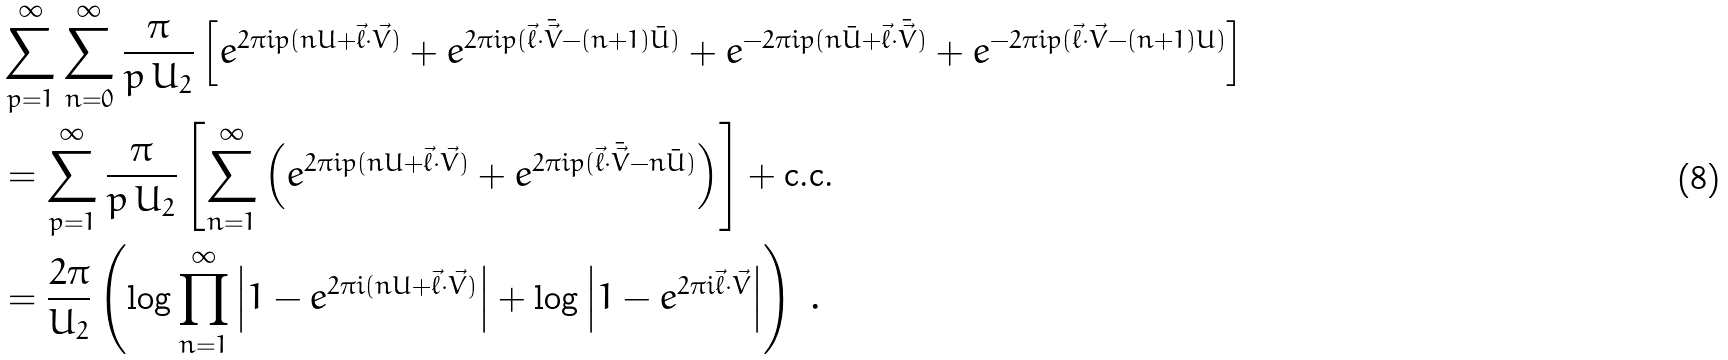Convert formula to latex. <formula><loc_0><loc_0><loc_500><loc_500>& \sum _ { p = 1 } ^ { \infty } \sum _ { n = 0 } ^ { \infty } \frac { \pi } { p \, U _ { 2 } } \left [ e ^ { 2 \pi i p ( n U + \vec { \ell } \cdot \vec { V } ) } + e ^ { 2 \pi i p ( \vec { \ell } \cdot \bar { \vec { V } } - ( n + 1 ) \bar { U } ) } + e ^ { - 2 \pi i p ( n \bar { U } + \vec { \ell } \cdot \bar { \vec { V } } ) } + e ^ { - 2 \pi i p ( \vec { \ell } \cdot \vec { V } - ( n + 1 ) U ) } \right ] \\ & = \sum _ { p = 1 } ^ { \infty } \frac { \pi } { p \, U _ { 2 } } \left [ \sum _ { n = 1 } ^ { \infty } \left ( e ^ { 2 \pi i p ( n U + \vec { \ell } \cdot \vec { V } ) } + e ^ { 2 \pi i p ( \vec { \ell } \cdot \bar { \vec { V } } - n \bar { U } ) } \right ) \right ] + \text {c.c.} \\ & = \frac { 2 \pi } { U _ { 2 } } \left ( \log \prod _ { n = 1 } ^ { \infty } \left | 1 - e ^ { 2 \pi i ( n U + \vec { \ell } \cdot \vec { V } ) } \right | + \log \left | 1 - e ^ { 2 \pi i \vec { \ell } \cdot \vec { V } } \right | \right ) \ .</formula> 